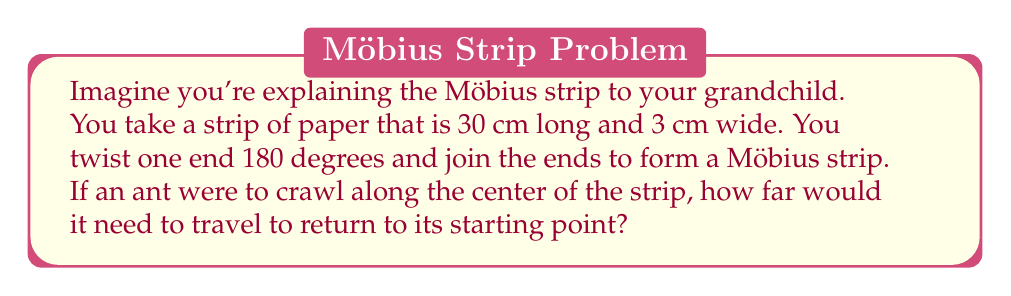Help me with this question. Let's approach this step-by-step, my dear:

1) First, we need to understand the nature of a Möbius strip. Unlike a regular cylinder, a Möbius strip has only one surface and one edge. This is due to the half-twist we give it before joining the ends.

2) When an ant crawls along the center of a Möbius strip, it will traverse the entire length of the strip twice before returning to its starting point. This is because:
   - On the first trip around, the ant ends up on what seems to be the "other side" of the strip.
   - It needs to go around once more to truly return to its starting point.

3) Mathematically, we can express this as:

   $$\text{Distance} = 2 \times \text{Length of strip}$$

4) We're given that the strip is 30 cm long. So:

   $$\text{Distance} = 2 \times 30\text{ cm} = 60\text{ cm}$$

5) This property demonstrates the concept of continuity in the Möbius strip. Despite the apparent twist, the surface remains continuous, allowing uninterrupted travel along its length.

Remember, my young one, just as this strip shows us unexpected connections, life often reveals surprising continuities if we keep an open mind and heart.
Answer: $60\text{ cm}$ 